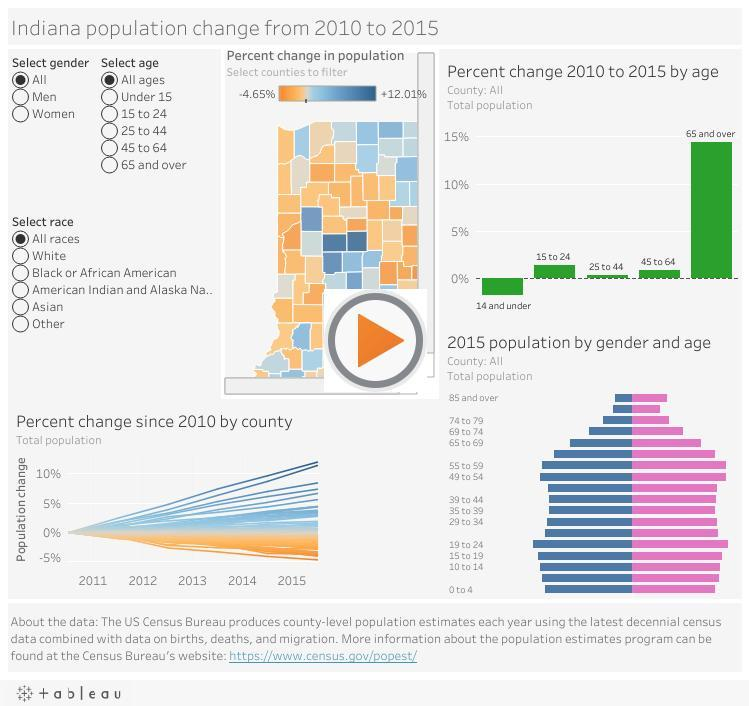How many races  not selected in this infographic
Answer the question with a short phrase. 5 What is the number of age groups not selected in this infographic? 5 